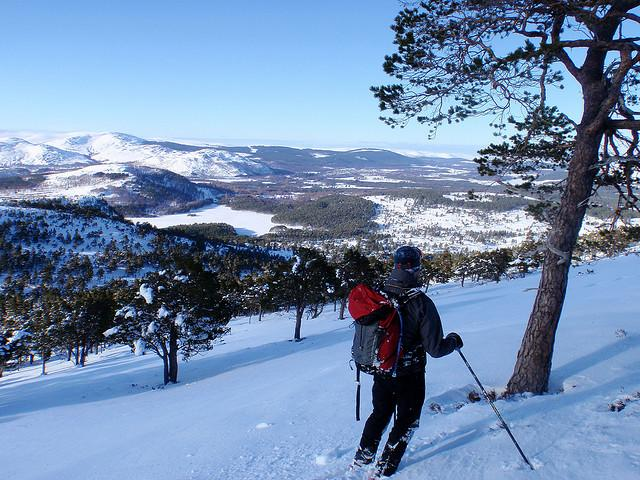What is the man doing in the snow? Please explain your reasoning. hiking. The man is hiking. 